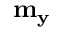Convert formula to latex. <formula><loc_0><loc_0><loc_500><loc_500>m _ { y }</formula> 